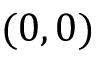Convert formula to latex. <formula><loc_0><loc_0><loc_500><loc_500>( 0 , 0 )</formula> 